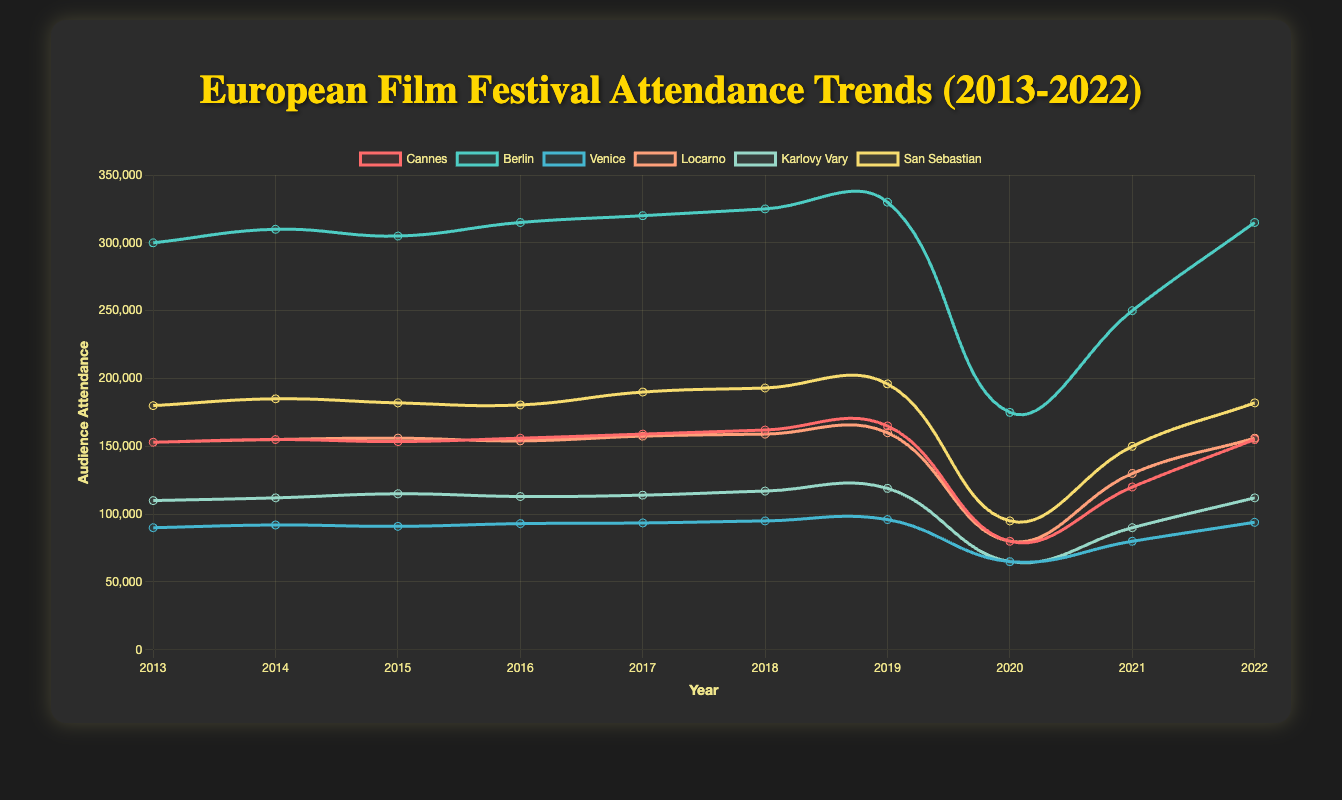What is the average attendance at the Berlin Film Festival between 2013 and 2019? The attendance for Berlin from 2013 to 2019 is: 300000, 310000, 305000, 315000, 320000, 325000, 330000. Summing these values gives 2205000. There are 7 years, so the average is 2205000 / 7 = 315000
Answer: 315000 In which year did the Cannes Film Festival experience the largest drop in attendance compared to the previous year? To find the largest drop, observe the difference in attendance year-on-year for Cannes. The largest drop is from 2019 to 2020, where the attendance fell from 165000 to 80000. The difference is 165000 - 80000 = 85000
Answer: 2020 Which two festivals had the closest attendance numbers in 2015? Comparing the attendance numbers in 2015: Cannes: 153500, Berlin: 305000, Venice: 91000, Locarno: 156000, Karlovy Vary: 115000, San Sebastian: 182000. The smallest difference is between Cannes (153500) and Locarno (156000) with a difference of 2500
Answer: Cannes and Locarno How did the attendance trend for the Venice Film Festival change from 2019 to 2021? In 2019, Venice had an attendance of 96000, which dropped to 65000 in 2020, and then increased to 80000 in 2021. Hence, there was a drop from 2019 to 2020, followed by an increase from 2020 to 2021
Answer: Dropped, then increased Which film festival showed the most consistent growth in attendance from 2013 to 2019? By visually assessing each festival's line from 2013 to 2019, Berlin shows the most consistent growth without any drops, with attendance increasing from 300000 to 330000
Answer: Berlin In 2020, which film festival had the lowest attendance, and what was the attendance number? By examining the values for 2020, the lowest attendance is for both Venice and Karlovy Vary, each with 65000 attendees
Answer: Venice and Karlovy Vary, 65000 What was the total attendance for all festivals combined in 2018? The attendances for 2018 are: Cannes: 162000, Berlin: 325000, Venice: 95000, Locarno: 159000, Karlovy Vary: 117000, San Sebastian: 193000. Summing these gives: 162000 + 325000 + 95000 + 159000 + 117000 + 193000 = 1051000
Answer: 1051000 Which film festival had the largest attendance in any single year, and what was the year and attendance? Checking the highest attendance values from the graph, Berlin had the largest attendance in 2019 with 330000 attendees
Answer: Berlin, 2019, 330000 How does the attendance of the San Sebastian Film Festival in 2022 compare to that in 2013? In 2022, San Sebastian had 182000 attendees and in 2013 it had 180000 attendees. The difference is 182000 - 180000 = 2000
Answer: Increased by 2000 Between 2016 and 2017, which festival had the smallest increase in attendance? Comparing the attendance increase between 2016 and 2017: Cannes: 3000, Berlin: 5000, Venice: 500, Locarno: 3500, Karlovy Vary: 1000, San Sebastian: 9500. The smallest increase is for Venice with 500
Answer: Venice 